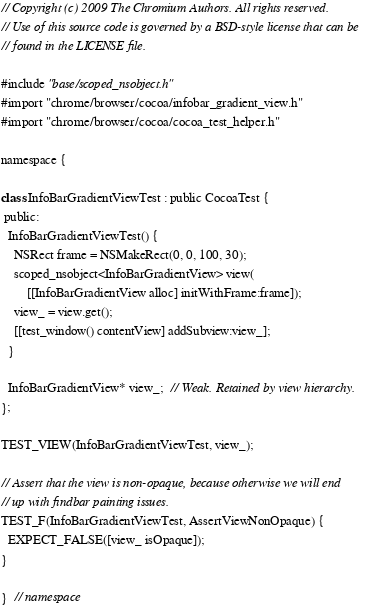<code> <loc_0><loc_0><loc_500><loc_500><_ObjectiveC_>// Copyright (c) 2009 The Chromium Authors. All rights reserved.
// Use of this source code is governed by a BSD-style license that can be
// found in the LICENSE file.

#include "base/scoped_nsobject.h"
#import "chrome/browser/cocoa/infobar_gradient_view.h"
#import "chrome/browser/cocoa/cocoa_test_helper.h"

namespace {

class InfoBarGradientViewTest : public CocoaTest {
 public:
  InfoBarGradientViewTest() {
    NSRect frame = NSMakeRect(0, 0, 100, 30);
    scoped_nsobject<InfoBarGradientView> view(
        [[InfoBarGradientView alloc] initWithFrame:frame]);
    view_ = view.get();
    [[test_window() contentView] addSubview:view_];
  }

  InfoBarGradientView* view_;  // Weak. Retained by view hierarchy.
};

TEST_VIEW(InfoBarGradientViewTest, view_);

// Assert that the view is non-opaque, because otherwise we will end
// up with findbar painting issues.
TEST_F(InfoBarGradientViewTest, AssertViewNonOpaque) {
  EXPECT_FALSE([view_ isOpaque]);
}

}  // namespace
</code> 